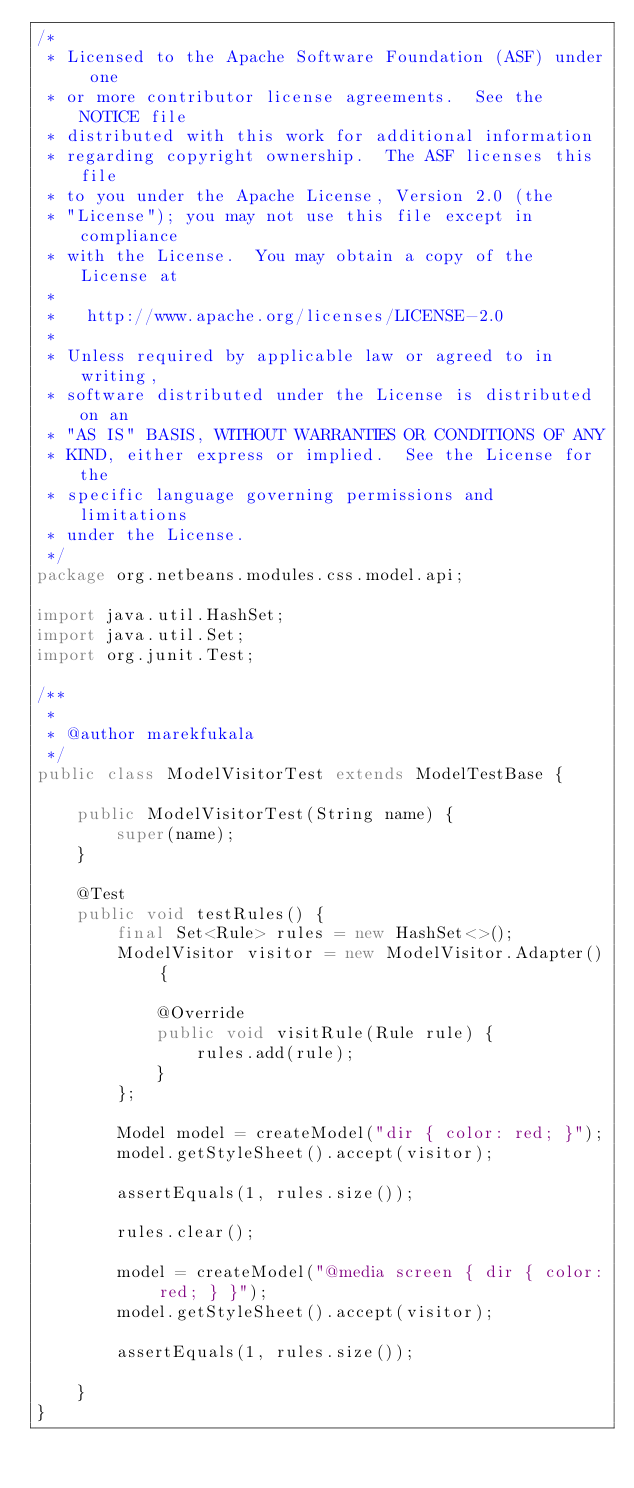Convert code to text. <code><loc_0><loc_0><loc_500><loc_500><_Java_>/*
 * Licensed to the Apache Software Foundation (ASF) under one
 * or more contributor license agreements.  See the NOTICE file
 * distributed with this work for additional information
 * regarding copyright ownership.  The ASF licenses this file
 * to you under the Apache License, Version 2.0 (the
 * "License"); you may not use this file except in compliance
 * with the License.  You may obtain a copy of the License at
 *
 *   http://www.apache.org/licenses/LICENSE-2.0
 *
 * Unless required by applicable law or agreed to in writing,
 * software distributed under the License is distributed on an
 * "AS IS" BASIS, WITHOUT WARRANTIES OR CONDITIONS OF ANY
 * KIND, either express or implied.  See the License for the
 * specific language governing permissions and limitations
 * under the License.
 */
package org.netbeans.modules.css.model.api;

import java.util.HashSet;
import java.util.Set;
import org.junit.Test;

/**
 *
 * @author marekfukala
 */
public class ModelVisitorTest extends ModelTestBase {
    
    public ModelVisitorTest(String name) {
        super(name);
    }

    @Test
    public void testRules() {
        final Set<Rule> rules = new HashSet<>();
        ModelVisitor visitor = new ModelVisitor.Adapter() {

            @Override
            public void visitRule(Rule rule) {
                rules.add(rule);
            }
        };
        
        Model model = createModel("dir { color: red; }");
        model.getStyleSheet().accept(visitor);
        
        assertEquals(1, rules.size());
        
        rules.clear();
        
        model = createModel("@media screen { dir { color: red; } }");
        model.getStyleSheet().accept(visitor);
        
        assertEquals(1, rules.size());
        
    }
}
</code> 